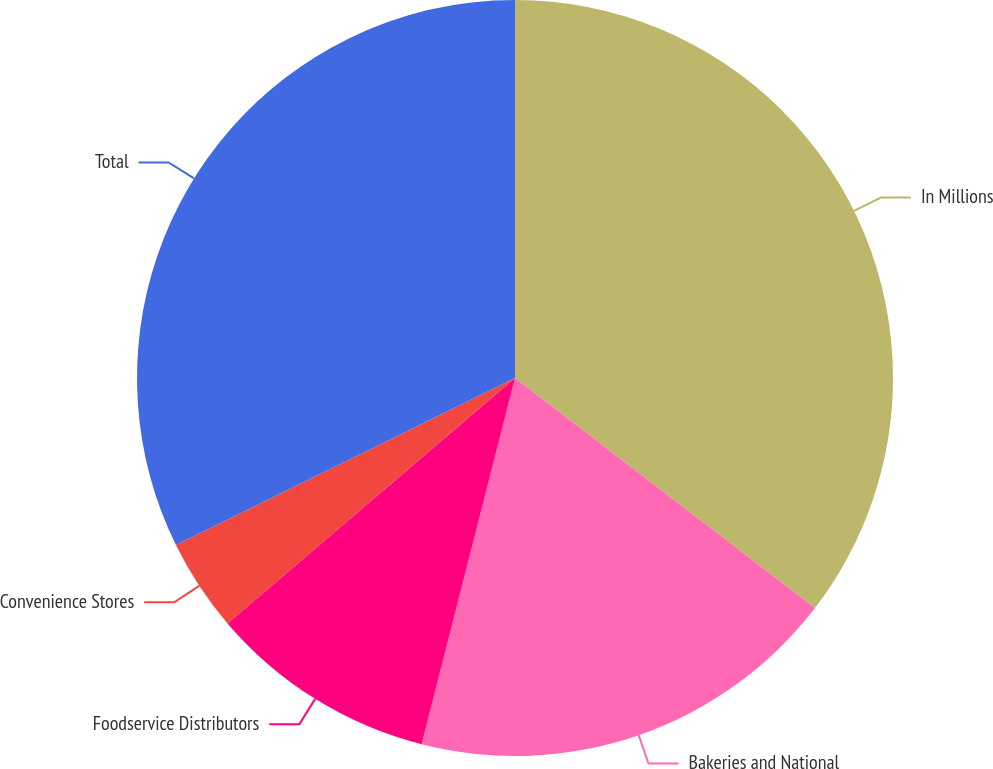Convert chart to OTSL. <chart><loc_0><loc_0><loc_500><loc_500><pie_chart><fcel>In Millions<fcel>Bakeries and National<fcel>Foodservice Distributors<fcel>Convenience Stores<fcel>Total<nl><fcel>35.42%<fcel>18.56%<fcel>9.78%<fcel>3.96%<fcel>32.29%<nl></chart> 